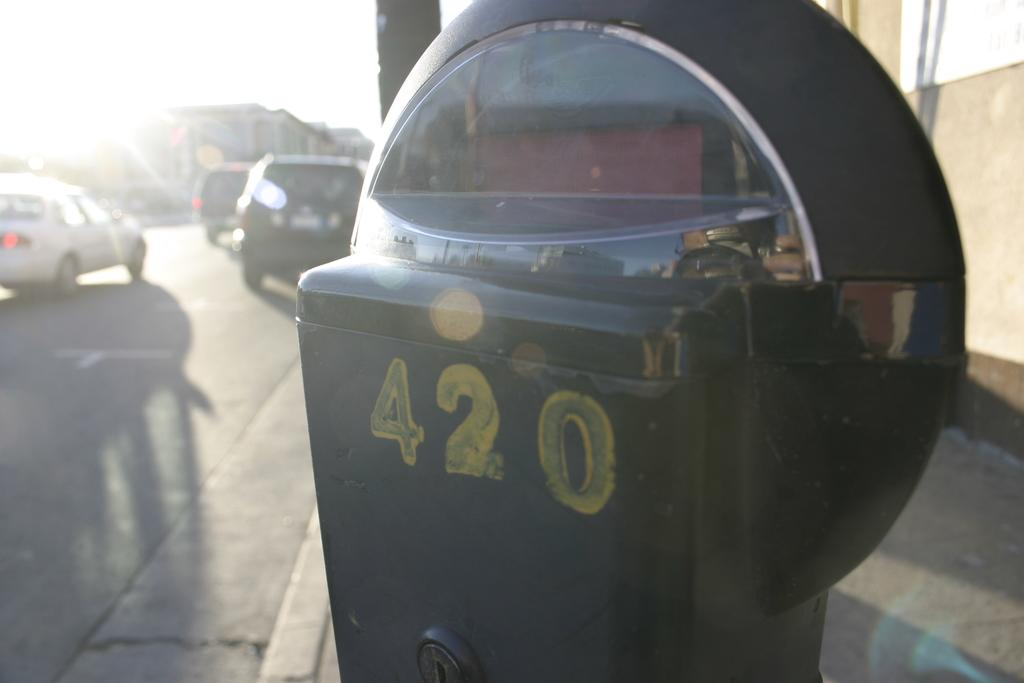<image>
Share a concise interpretation of the image provided. The number 420 is painted in yellow on a meter. 